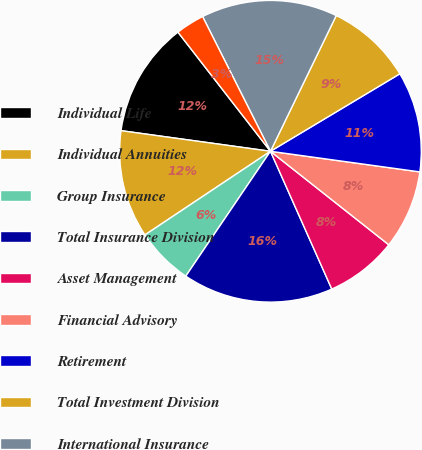<chart> <loc_0><loc_0><loc_500><loc_500><pie_chart><fcel>Individual Life<fcel>Individual Annuities<fcel>Group Insurance<fcel>Total Insurance Division<fcel>Asset Management<fcel>Financial Advisory<fcel>Retirement<fcel>Total Investment Division<fcel>International Insurance<fcel>International Investments<nl><fcel>12.31%<fcel>11.54%<fcel>6.16%<fcel>16.15%<fcel>7.69%<fcel>8.46%<fcel>10.77%<fcel>9.23%<fcel>14.61%<fcel>3.08%<nl></chart> 